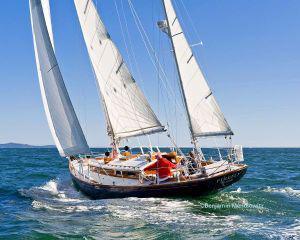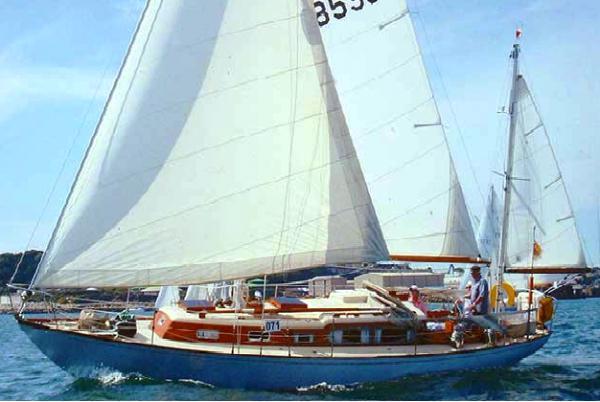The first image is the image on the left, the second image is the image on the right. For the images displayed, is the sentence "In one image, a moving sailboat's three triangular sails are angled with their peaks toward the upper left." factually correct? Answer yes or no. Yes. 